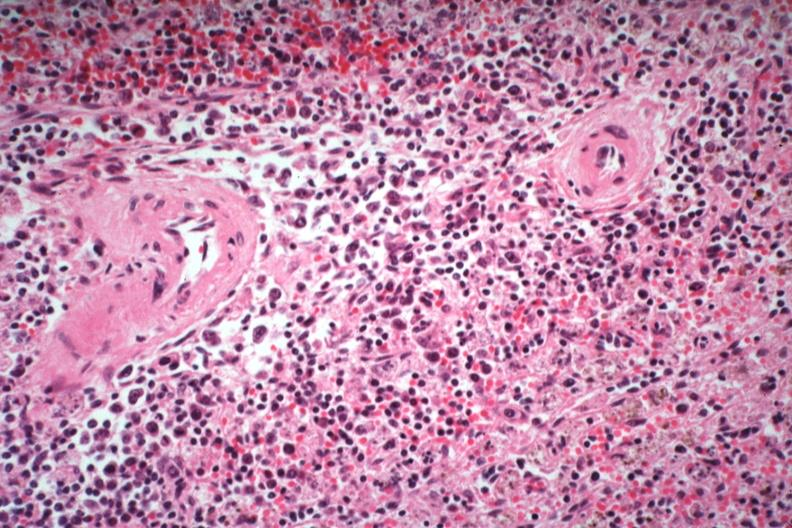what is present?
Answer the question using a single word or phrase. Hematologic 